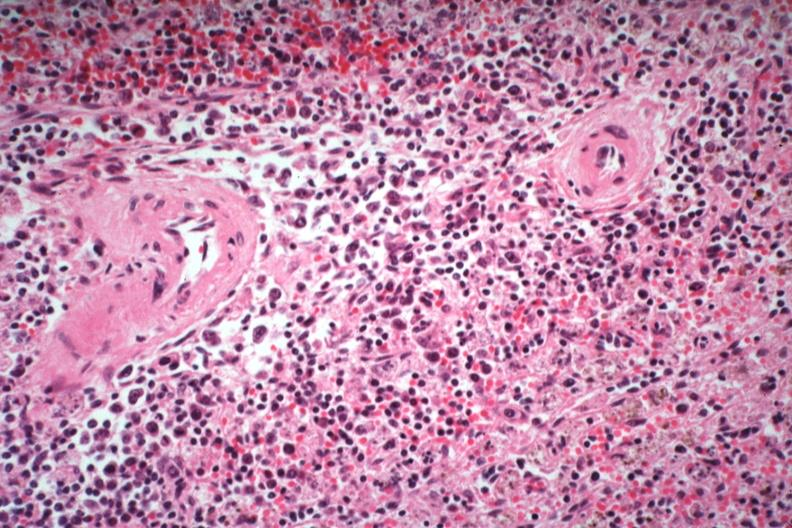what is present?
Answer the question using a single word or phrase. Hematologic 